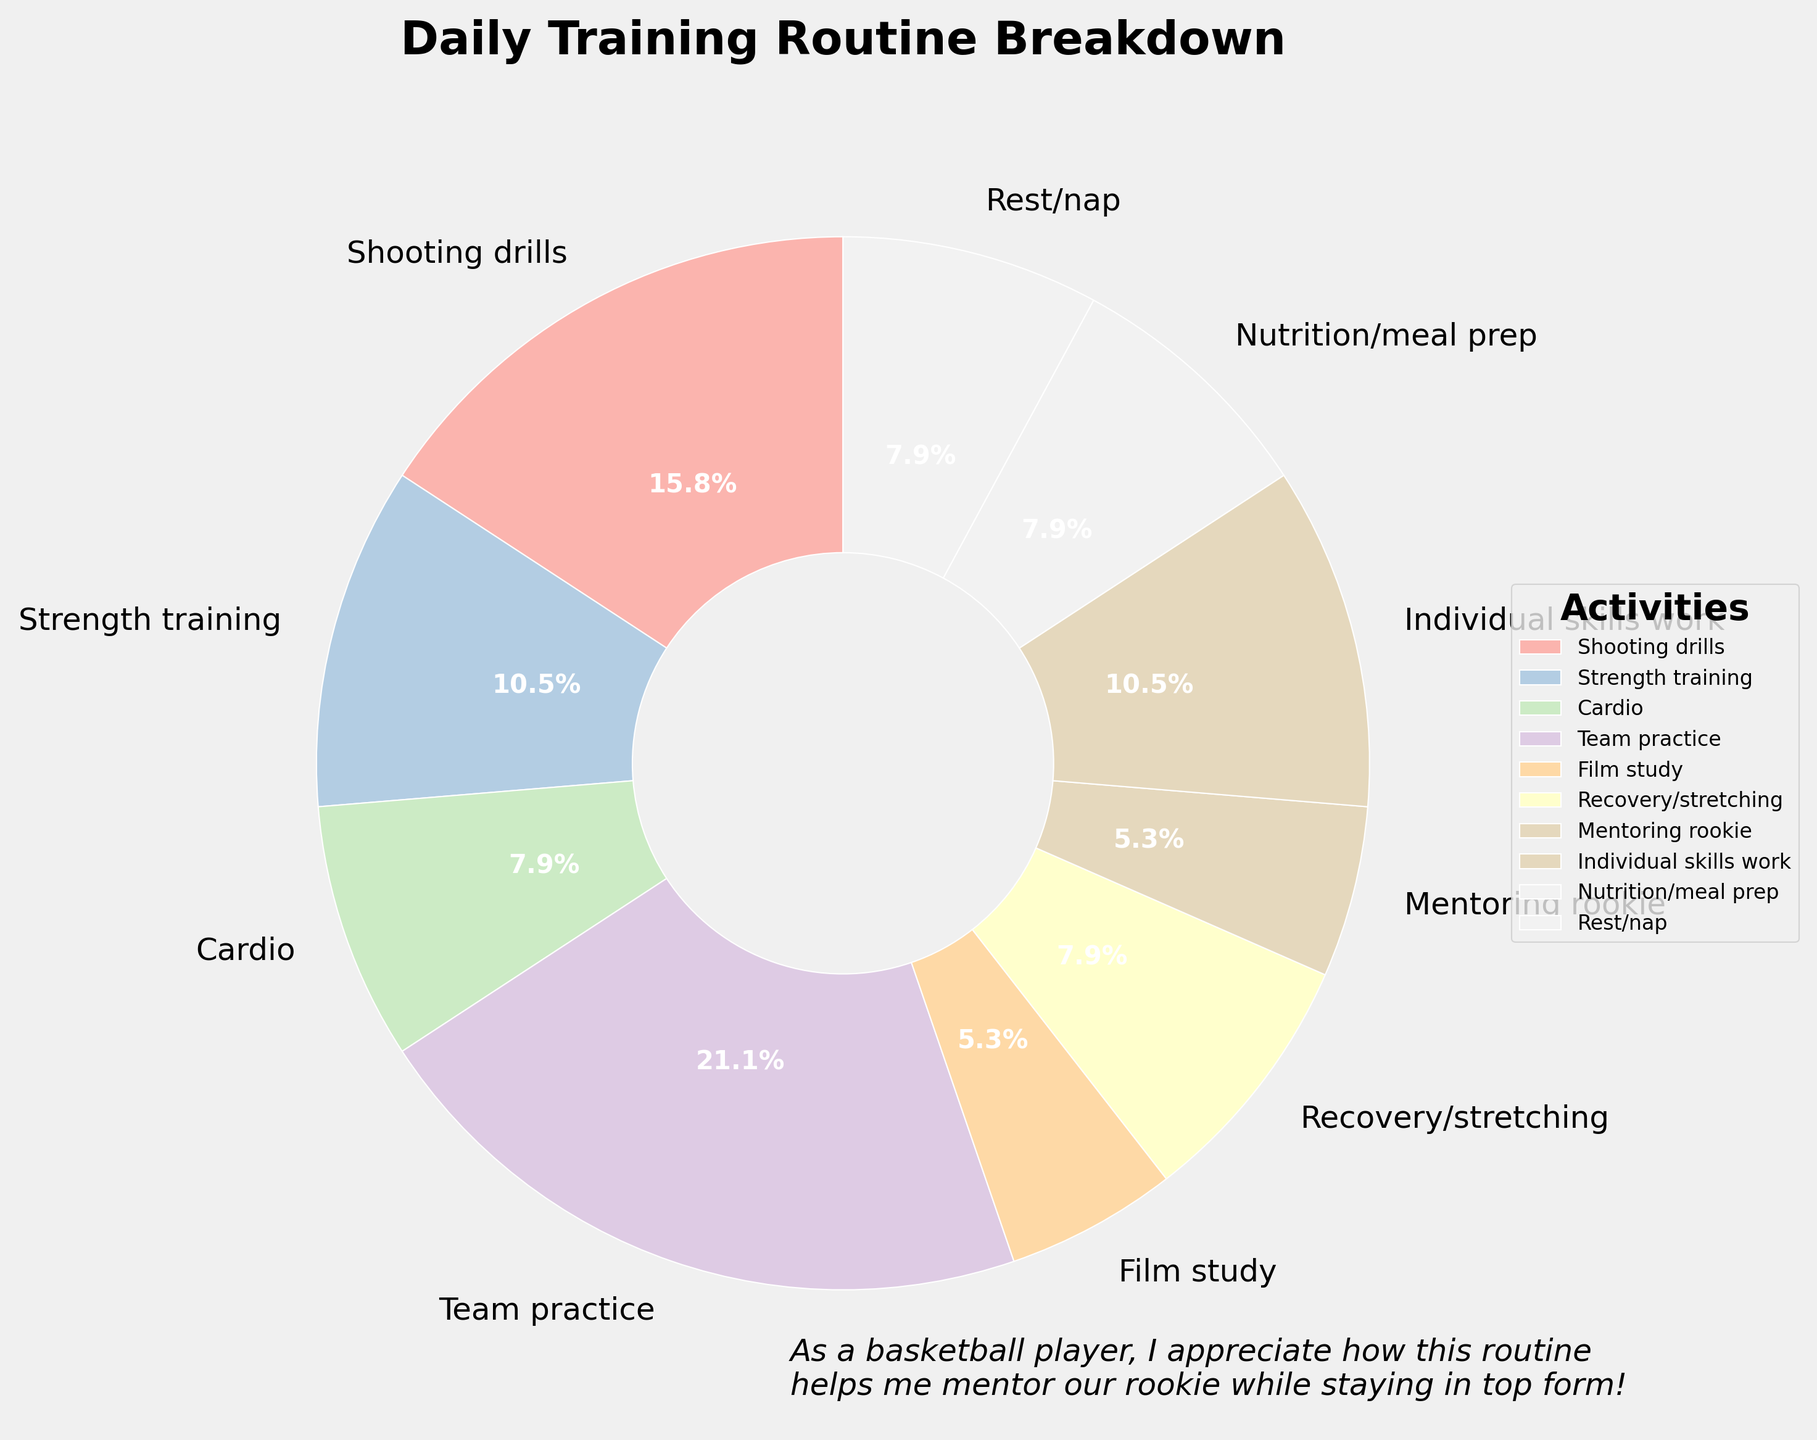What's the largest activity in the basketball player's daily training routine? The pie chart shows the breakdown of different activities. The largest wedge corresponds to Team practice, making it the largest activity.
Answer: Team practice Which activity takes up more minutes, Shooting drills or Strength training? From the pie chart, Shooting drills take 90 minutes, and Strength training takes 60 minutes. Since 90 > 60, Shooting drills take up more minutes.
Answer: Shooting drills What is the total time spent on cardio, recovery/stretching, and nutrition/meal prep combined? From the pie chart, Cardio takes 45 minutes, Recovery/stretching 45 minutes, and Nutrition/meal prep 45 minutes. Adding them: 45 + 45 + 45 = 135 minutes.
Answer: 135 minutes Is more time spent on Team practice or combined on Recovery/stretching and Mentoring rookie? Team practice takes 120 minutes. Recovery/stretching takes 45 minutes and Mentoring rookie takes 30 minutes. The combined time is 45 + 30 = 75 minutes. Since 120 > 75, more time is spent on Team practice.
Answer: Team practice How much time is spent on individual activities compared to team-oriented activities like Team practice and Mentoring rookie? Individual activities: Shooting drills 90 min, Strength training 60 min, Cardio 45 min, Film study 30 min, Individual skills work 60 min, Nutrition/meal prep 45 min, Recovery/stretching 45 min, Rest/nap 45 min. Add individual: 90 + 60 + 45 + 30 + 60 + 45 + 45 + 45 = 420 min. Team-oriented: Team practice 120 min, Mentoring rookie 30 min. Add team-oriented: 120 + 30 = 150 min. Comparing, 420 > 150.
Answer: More time on individual activities Which activity occupies a percentage of less than 10% of the daily routine? By looking at the pie chart, Film study shows a smaller wedge labeled with 5.0%, indicating it occupies less than 10% of the daily routine.
Answer: Film study If you combine the activities Film study and Mentoring rookie, what percentage do they cover together in the routine? Film study covers 5.0% and Mentoring rookie covers 5.0%, combined they make 5.0% + 5.0% = 10.0%.
Answer: 10.0% Compare the time spent on Recovery/stretching and Rest/nap; are they equal, more or less than each other? From the pie chart, both Recovery/stretching and Rest/nap take 45 minutes each. Since 45 = 45, they are equal.
Answer: Equal What is the total time dedicated to drills and skills-related activities (Shooting drills and Individual skills work)? Shooting drills take 90 minutes and Individual skills work takes 60 minutes. Adding these: 90 + 60 = 150 minutes.
Answer: 150 minutes 